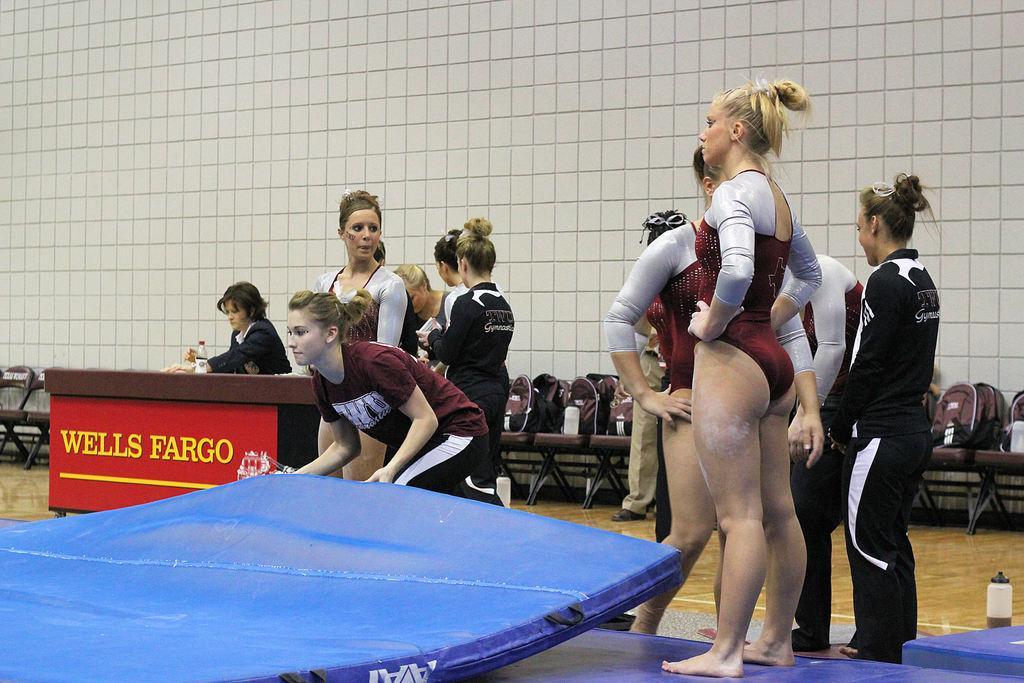In one or two sentences, can you explain what this image depicts? In this picture I can see number of women in front who are wearing costumes and I see the blue color mats in front. I can also see a woman is holding the mat. In the background I can see the chairs and on the left side of this picture I can see a table on which there is a bottle and behind it I can see a woman. On the bottom right corner of this picture I can see another bottle and I can see the wall and I see something is written on the table. 